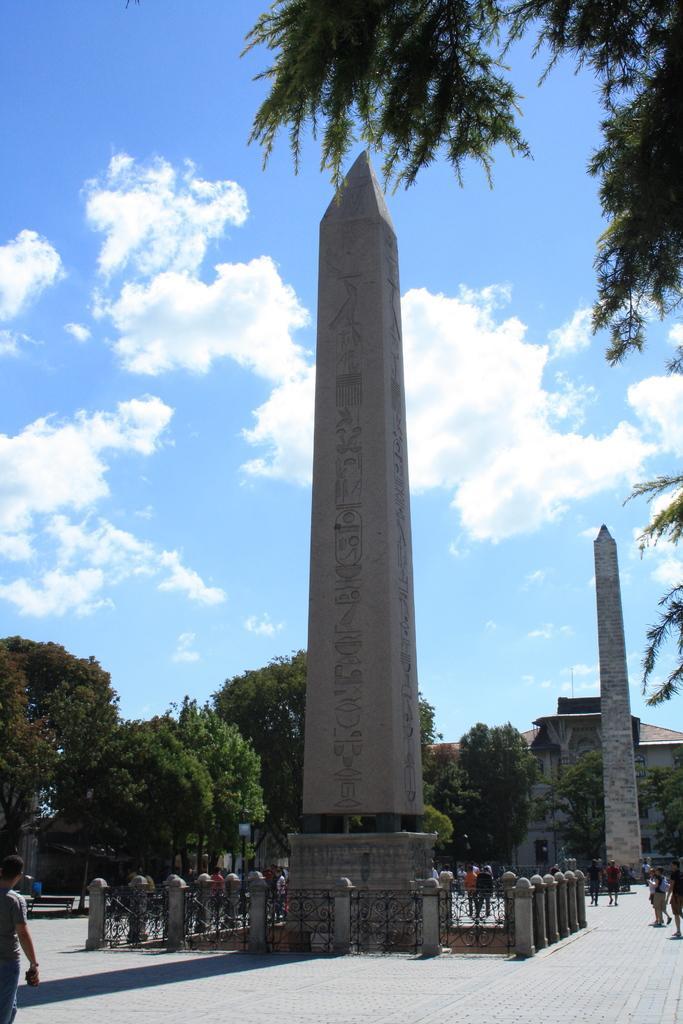Could you give a brief overview of what you see in this image? In this picture I can observe two obelisks. In the background there are trees and some clouds in the sky. 